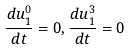<formula> <loc_0><loc_0><loc_500><loc_500>\frac { d u _ { 1 } ^ { 0 } } { d t } = 0 , \frac { d u _ { 1 } ^ { 3 } } { d t } = 0</formula> 